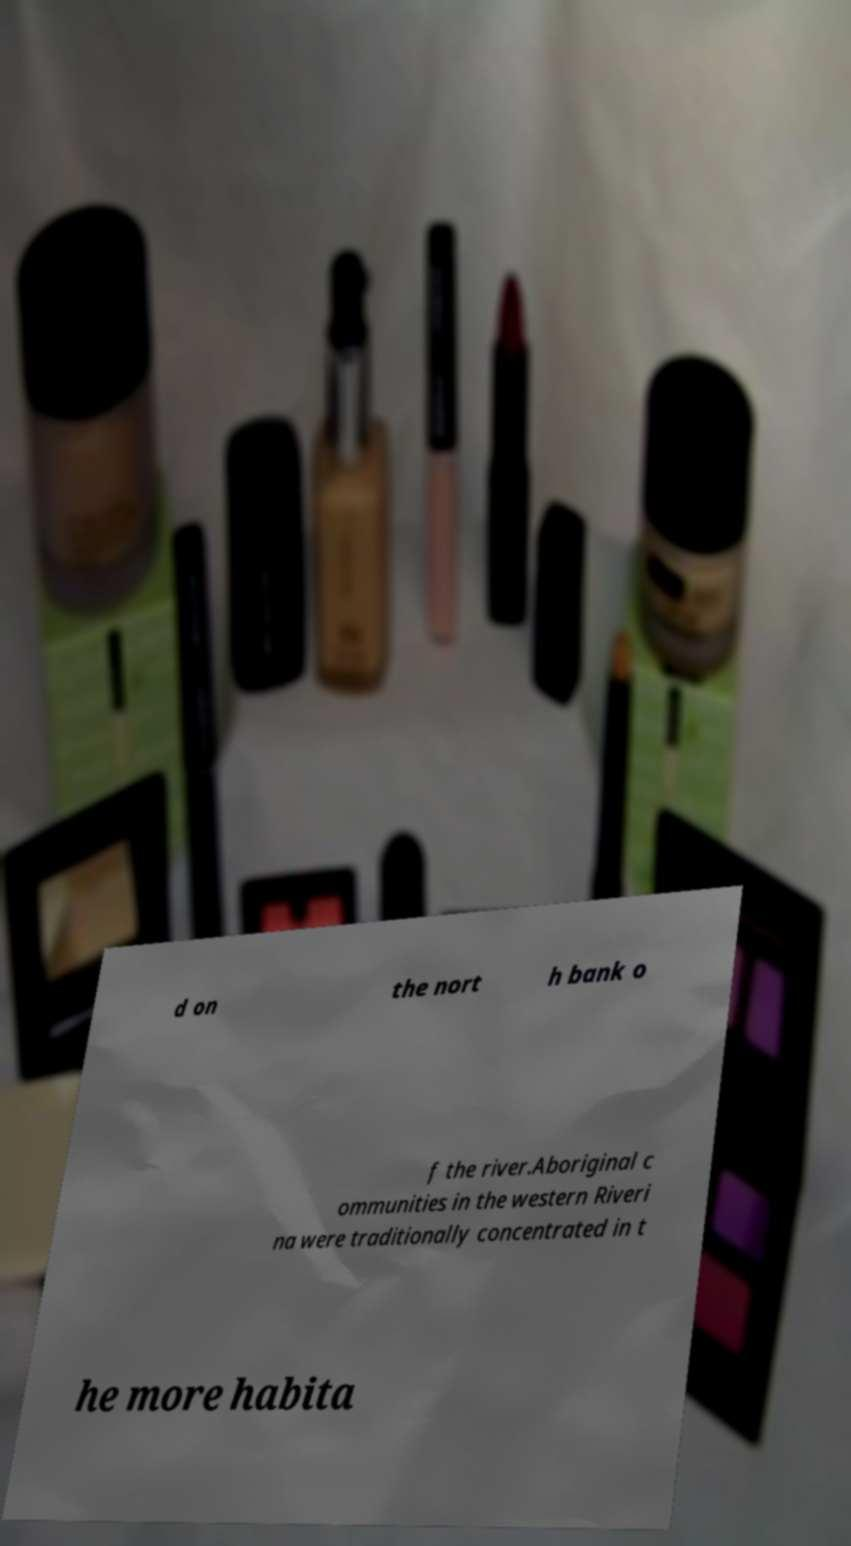Could you assist in decoding the text presented in this image and type it out clearly? d on the nort h bank o f the river.Aboriginal c ommunities in the western Riveri na were traditionally concentrated in t he more habita 